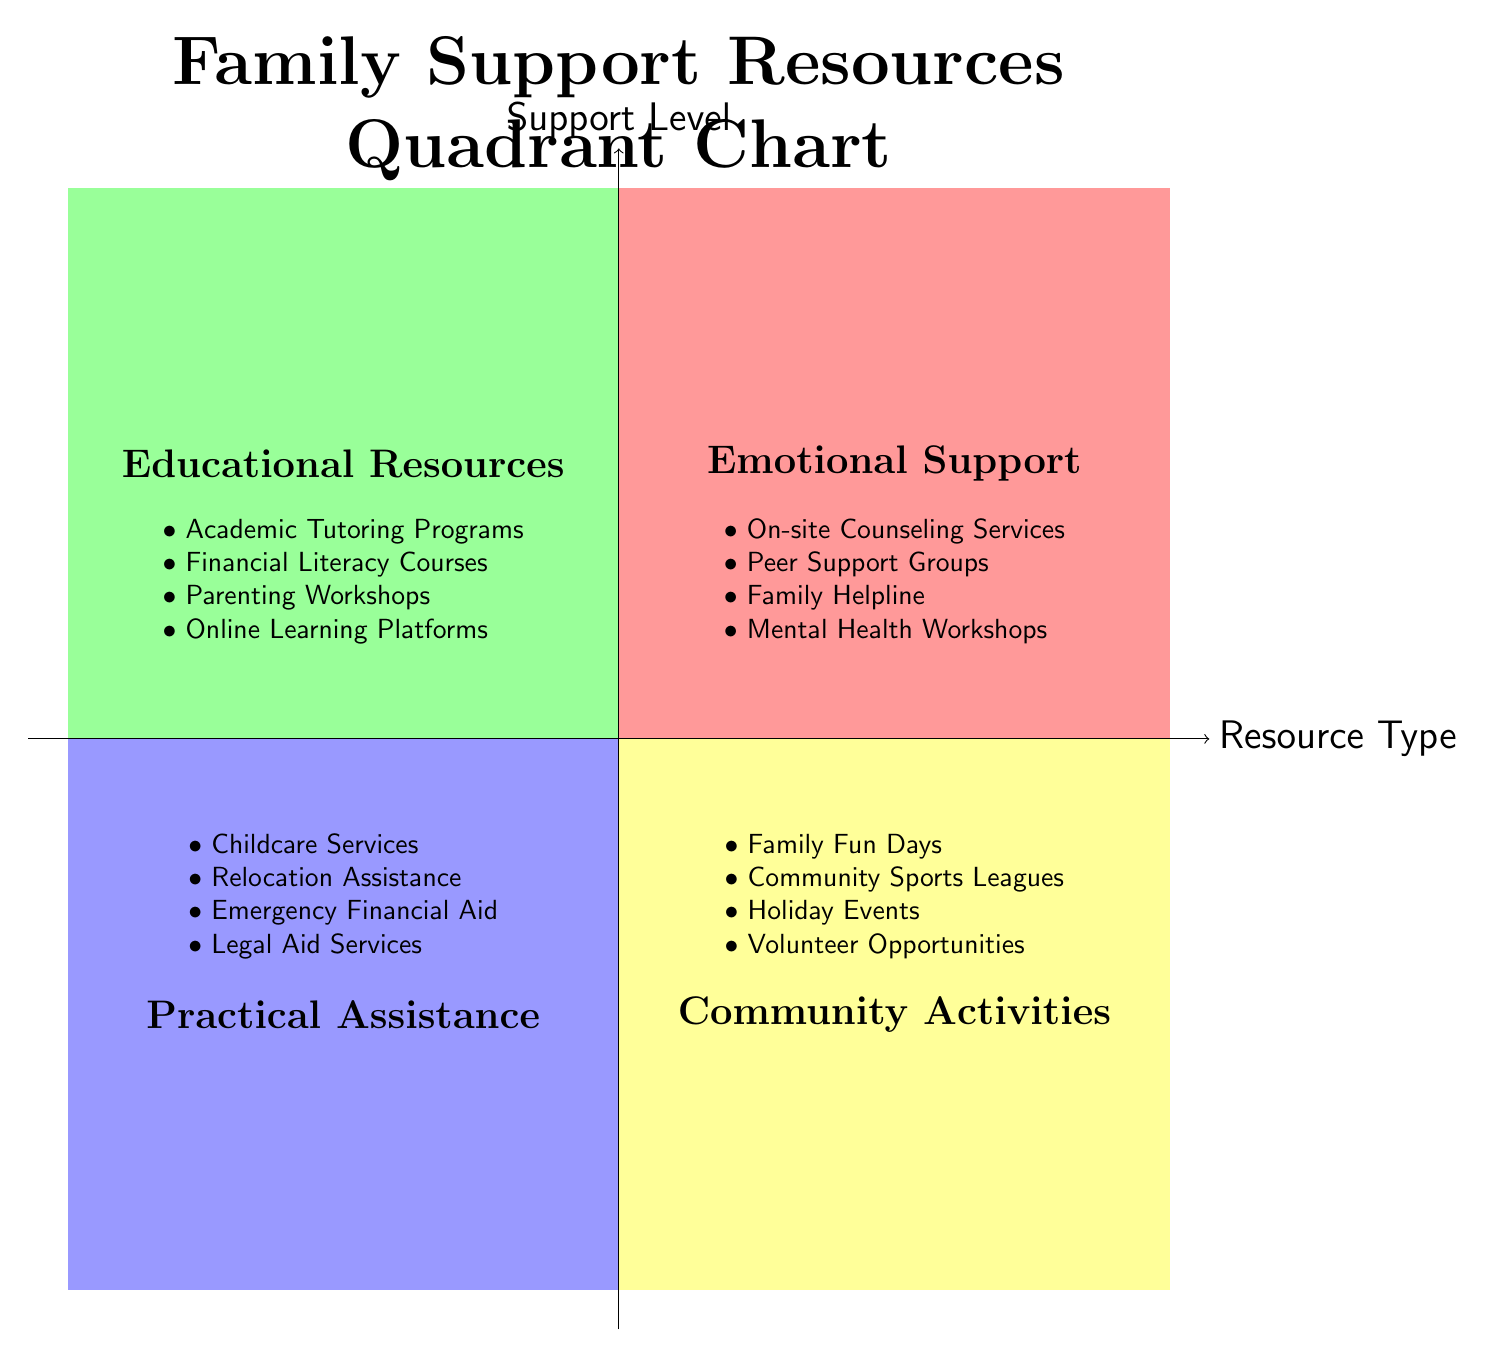What category includes Peer Support Groups? Peer Support Groups are listed under the "Emotional Support" quadrant of the diagram. This quadrant contains resources focused on providing emotional and mental health assistance.
Answer: Emotional Support How many elements are listed under Community Activities? The "Community Activities" quadrant includes four specific elements: Family Fun Days, Community Sports Leagues, Holiday Events, and Volunteer Opportunities. This indicates the variety of community engagement options available.
Answer: 4 Which quadrant contains Academic Tutoring Programs? Academic Tutoring Programs are found in the "Educational Resources" quadrant. This quadrant is dedicated to resources that help with education and learning skills for families.
Answer: Educational Resources What is the primary theme of the Practical Assistance quadrant? The "Practical Assistance" quadrant focuses on tangible support services for families, such as childcare, financial aid, and legal assistance. The underlying theme is helping families manage practical challenges.
Answer: Practical Assistance Which quadrant is focused on workshops? The "Emotional Support" quadrant includes Mental Health Workshops, while the "Educational Resources" quadrant includes Parenting Workshops and Financial Literacy Courses. However, the primary focus on workshops as a support service is in both the Emotional Support and Educational Resources quadrants.
Answer: Emotional Support and Educational Resources What resources are associated with the highest level of support in this chart? The highest level of support is represented by the "Emotional Support" quadrant, which includes crucial resources like On-site Counseling Services and Peer Support Groups aimed at addressing mental health and emotional needs.
Answer: Emotional Support Which quadrant offers legal aid services? Legal Aid Services are listed in the "Practical Assistance" quadrant, which focuses on facilitating necessary resources for family stability and support in legal matters.
Answer: Practical Assistance What is the theme of the Community Activities quadrant? The "Community Activities" quadrant promotes engaging and recreational activities designed to strengthen community bonds among families, as illustrated by various events and leagues.
Answer: Community Activities 